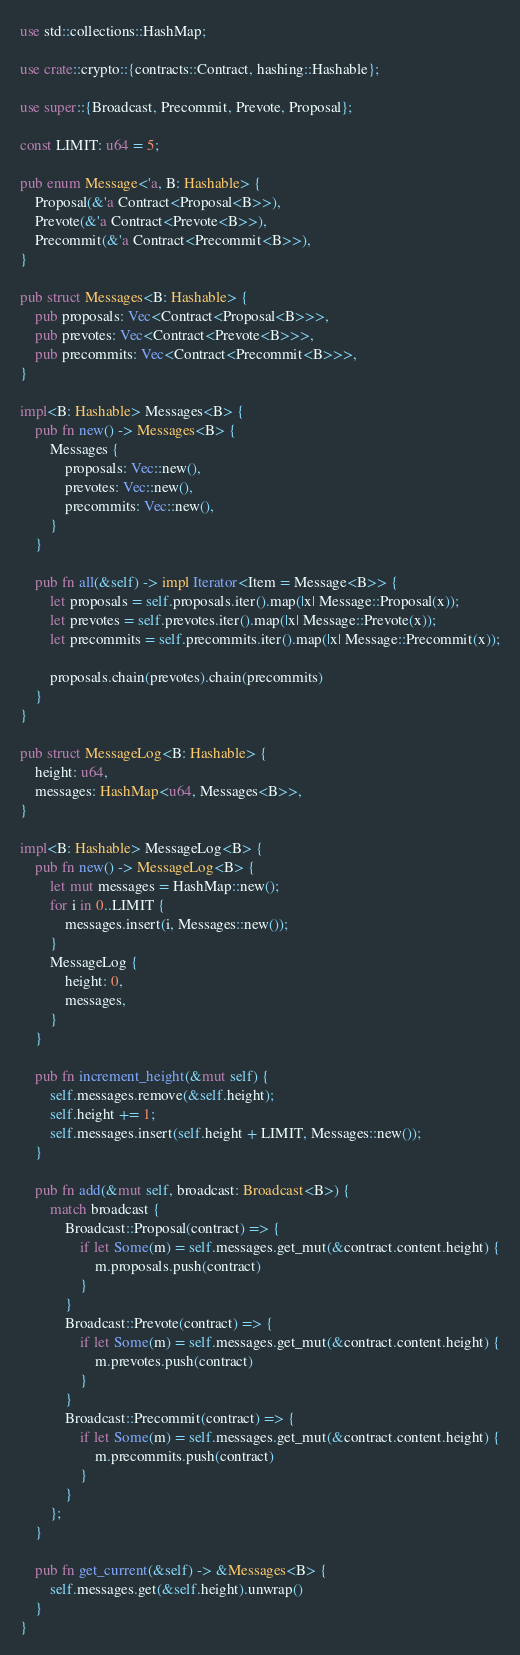<code> <loc_0><loc_0><loc_500><loc_500><_Rust_>use std::collections::HashMap;

use crate::crypto::{contracts::Contract, hashing::Hashable};

use super::{Broadcast, Precommit, Prevote, Proposal};

const LIMIT: u64 = 5;

pub enum Message<'a, B: Hashable> {
    Proposal(&'a Contract<Proposal<B>>),
    Prevote(&'a Contract<Prevote<B>>),
    Precommit(&'a Contract<Precommit<B>>),
}

pub struct Messages<B: Hashable> {
    pub proposals: Vec<Contract<Proposal<B>>>,
    pub prevotes: Vec<Contract<Prevote<B>>>,
    pub precommits: Vec<Contract<Precommit<B>>>,
}

impl<B: Hashable> Messages<B> {
    pub fn new() -> Messages<B> {
        Messages {
            proposals: Vec::new(),
            prevotes: Vec::new(),
            precommits: Vec::new(),
        }
    }

    pub fn all(&self) -> impl Iterator<Item = Message<B>> {
        let proposals = self.proposals.iter().map(|x| Message::Proposal(x));
        let prevotes = self.prevotes.iter().map(|x| Message::Prevote(x));
        let precommits = self.precommits.iter().map(|x| Message::Precommit(x));

        proposals.chain(prevotes).chain(precommits)
    }
}

pub struct MessageLog<B: Hashable> {
    height: u64,
    messages: HashMap<u64, Messages<B>>,
}

impl<B: Hashable> MessageLog<B> {
    pub fn new() -> MessageLog<B> {
        let mut messages = HashMap::new();
        for i in 0..LIMIT {
            messages.insert(i, Messages::new());
        }
        MessageLog {
            height: 0,
            messages,
        }
    }

    pub fn increment_height(&mut self) {
        self.messages.remove(&self.height);
        self.height += 1;
        self.messages.insert(self.height + LIMIT, Messages::new());
    }

    pub fn add(&mut self, broadcast: Broadcast<B>) {
        match broadcast {
            Broadcast::Proposal(contract) => {
                if let Some(m) = self.messages.get_mut(&contract.content.height) {
                    m.proposals.push(contract)
                }
            }
            Broadcast::Prevote(contract) => {
                if let Some(m) = self.messages.get_mut(&contract.content.height) {
                    m.prevotes.push(contract)
                }
            }
            Broadcast::Precommit(contract) => {
                if let Some(m) = self.messages.get_mut(&contract.content.height) {
                    m.precommits.push(contract)
                }
            }
        };
    }

    pub fn get_current(&self) -> &Messages<B> {
        self.messages.get(&self.height).unwrap()
    }
}
</code> 